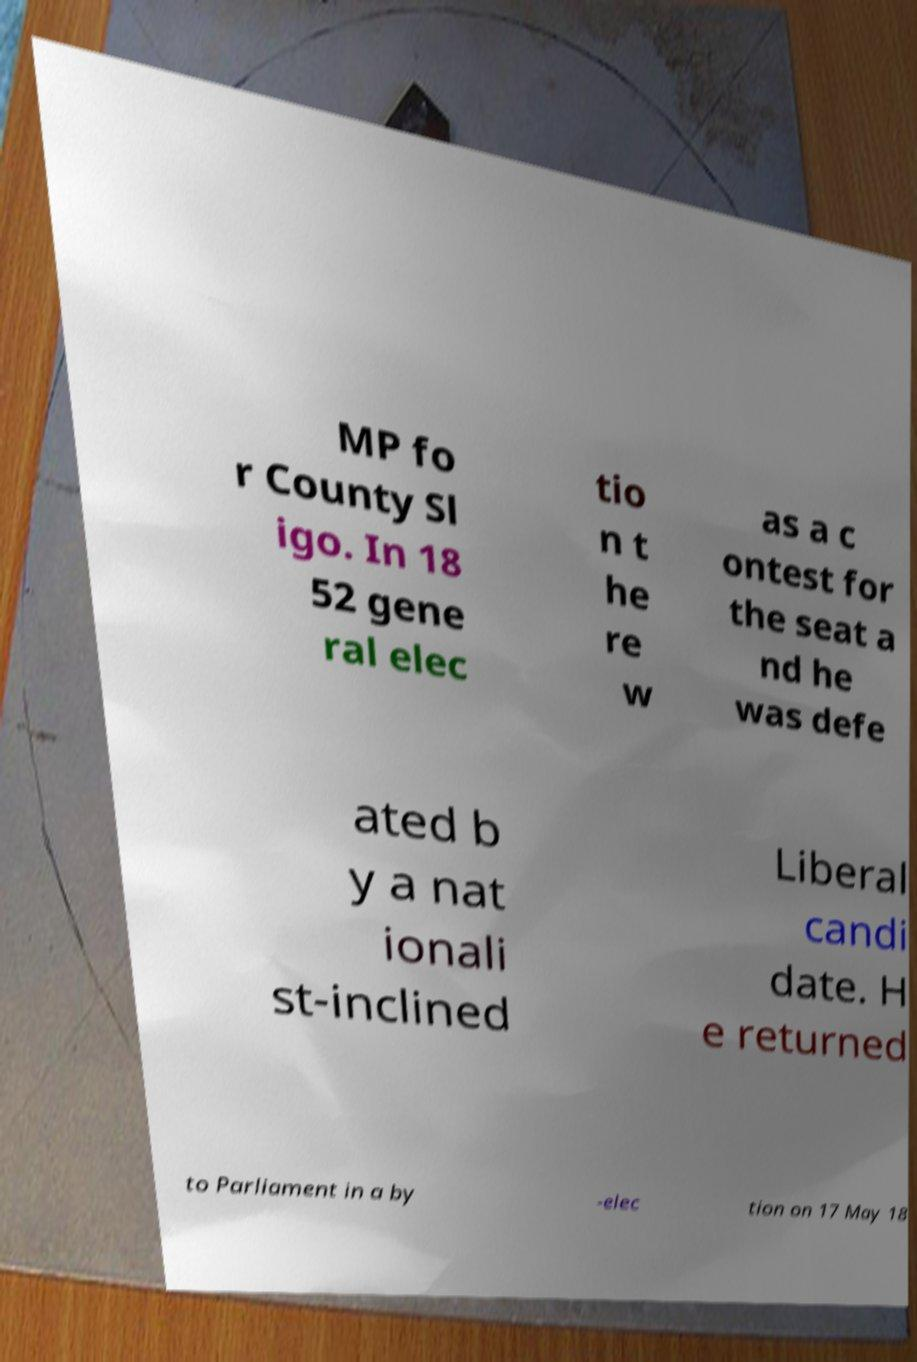Could you extract and type out the text from this image? MP fo r County Sl igo. In 18 52 gene ral elec tio n t he re w as a c ontest for the seat a nd he was defe ated b y a nat ionali st-inclined Liberal candi date. H e returned to Parliament in a by -elec tion on 17 May 18 